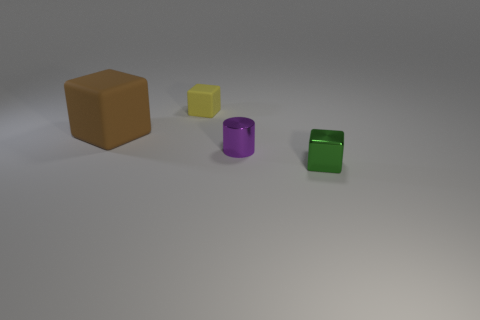What can you infer about the lighting in the scene? The shadows of the objects indicate that the light source is coming from the upper left side of the image, casting soft-edged shadows to the right of each object. The lighting appears to be artificial, given the controlled shadow direction and intensity. 